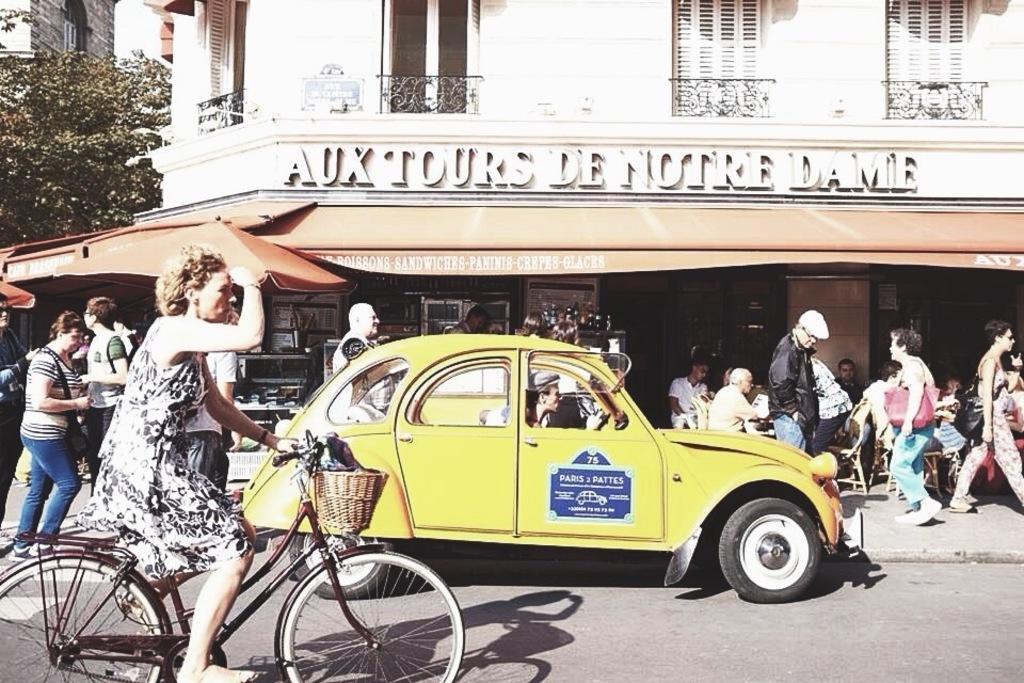Describe this image in one or two sentences. In this image I can see a woman riding a bicycle and there are few people walking on the road and there is a person riding a car on the road. At the back side we can a building and a store. There are trees. 